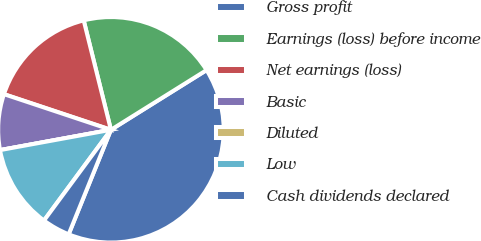Convert chart. <chart><loc_0><loc_0><loc_500><loc_500><pie_chart><fcel>Gross profit<fcel>Earnings (loss) before income<fcel>Net earnings (loss)<fcel>Basic<fcel>Diluted<fcel>Low<fcel>Cash dividends declared<nl><fcel>40.0%<fcel>20.0%<fcel>16.0%<fcel>8.0%<fcel>0.0%<fcel>12.0%<fcel>4.0%<nl></chart> 